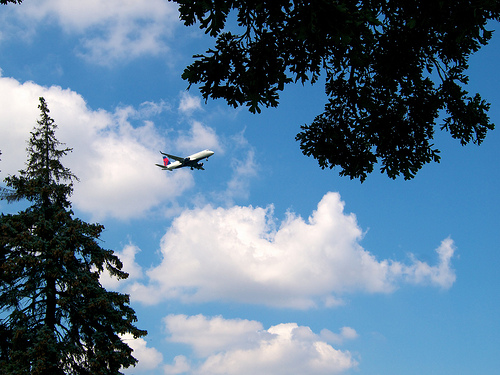How many planes are there? There is one plane visible in the image, gracefully soaring through the sky amidst a backdrop of fluffy, white clouds. 